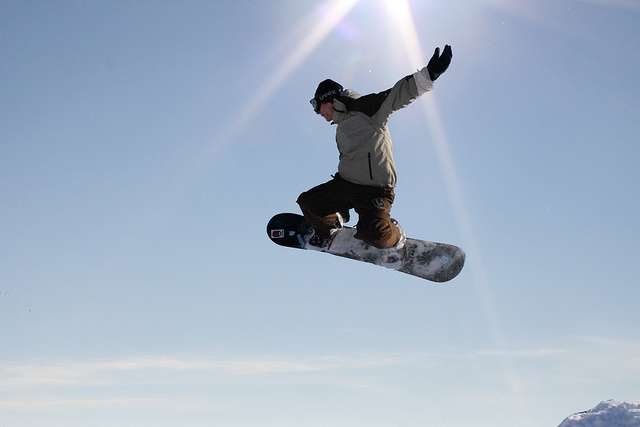Describe the objects in this image and their specific colors. I can see people in gray, black, and darkgray tones and snowboard in gray and black tones in this image. 